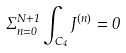Convert formula to latex. <formula><loc_0><loc_0><loc_500><loc_500>\Sigma ^ { N + 1 } _ { n = 0 } \int _ { C _ { 4 } } J ^ { ( n ) } = 0</formula> 